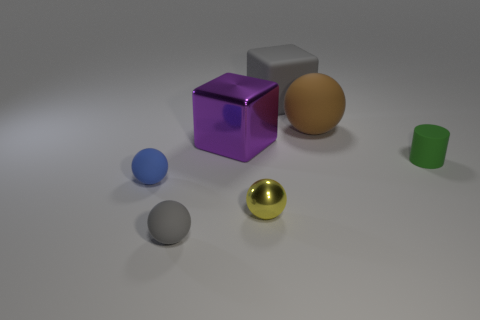Subtract 1 spheres. How many spheres are left? 3 Add 2 large gray shiny cylinders. How many objects exist? 9 Subtract all cubes. How many objects are left? 5 Subtract 0 brown cubes. How many objects are left? 7 Subtract all gray things. Subtract all rubber objects. How many objects are left? 0 Add 2 gray cubes. How many gray cubes are left? 3 Add 6 blue metal things. How many blue metal things exist? 6 